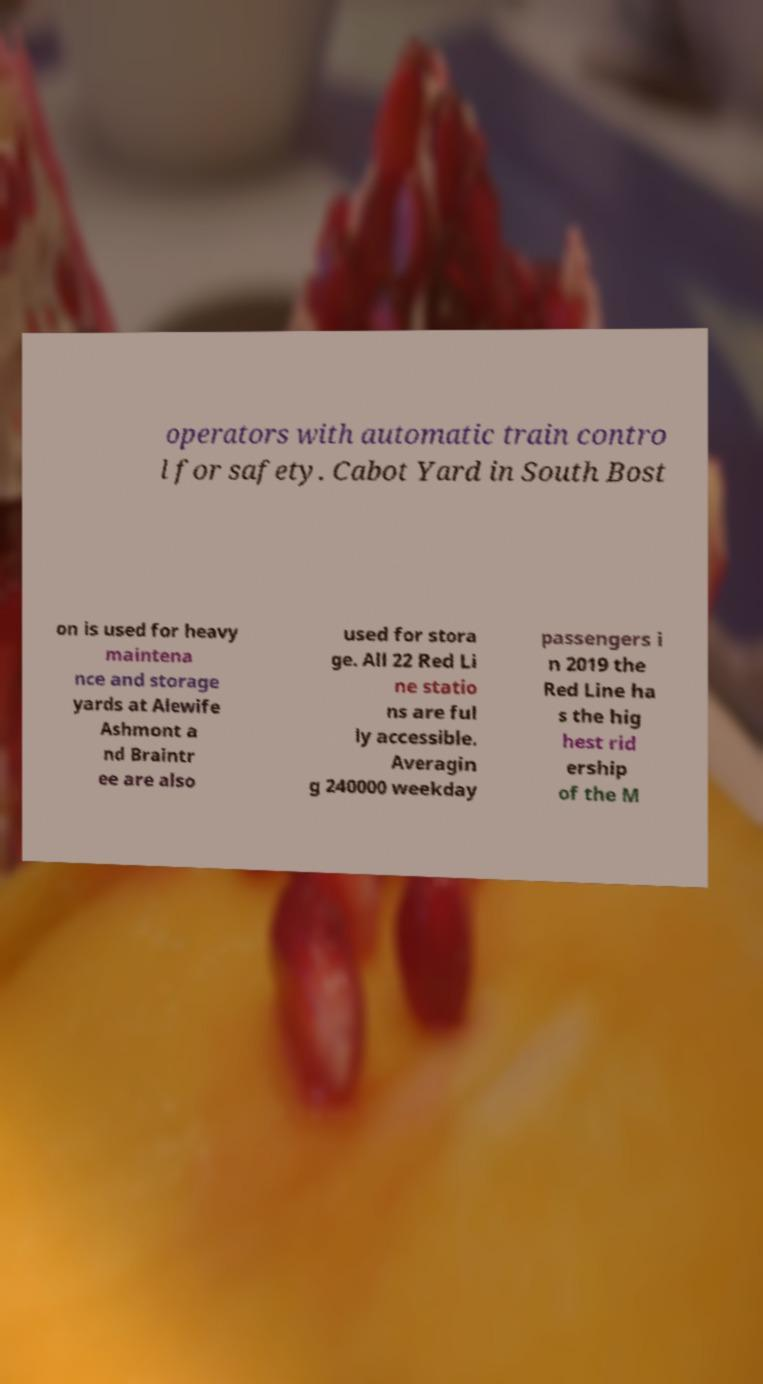There's text embedded in this image that I need extracted. Can you transcribe it verbatim? operators with automatic train contro l for safety. Cabot Yard in South Bost on is used for heavy maintena nce and storage yards at Alewife Ashmont a nd Braintr ee are also used for stora ge. All 22 Red Li ne statio ns are ful ly accessible. Averagin g 240000 weekday passengers i n 2019 the Red Line ha s the hig hest rid ership of the M 